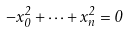<formula> <loc_0><loc_0><loc_500><loc_500>- x _ { 0 } ^ { 2 } + \cdots + x _ { n } ^ { 2 } = 0</formula> 